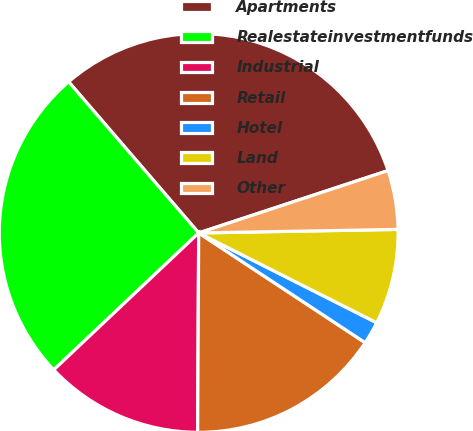<chart> <loc_0><loc_0><loc_500><loc_500><pie_chart><fcel>Apartments<fcel>Realestateinvestmentfunds<fcel>Industrial<fcel>Retail<fcel>Hotel<fcel>Land<fcel>Other<nl><fcel>31.25%<fcel>25.74%<fcel>12.87%<fcel>15.81%<fcel>1.84%<fcel>7.72%<fcel>4.78%<nl></chart> 